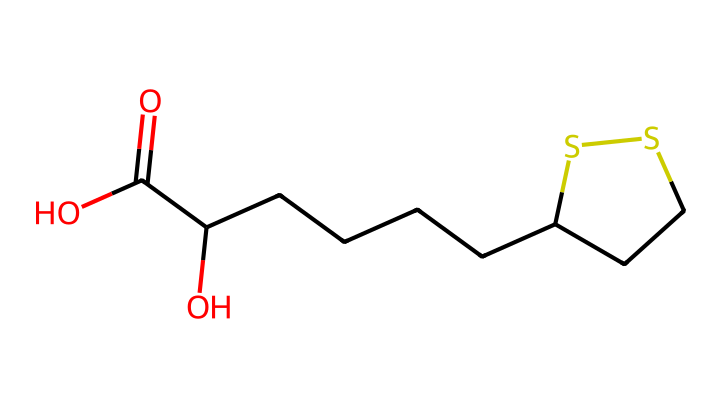What is the molecular formula of alpha-lipoic acid? By analyzing the SMILES representation, we can identify the components which typically include carbon (C), hydrogen (H), oxygen (O), and sulfur (S). Counting the atoms, we find there are 8 carbon atoms, 14 hydrogen atoms, 2 oxygen atoms, and 2 sulfur atoms. This leads us to the molecular formula, which combines these counts.
Answer: C8H14O2S2 How many sulfur atoms are in alpha-lipoic acid? In the SMILES notation, the "S" represents sulfur atoms. By counting the occurrences of "S," we find there are 2 sulfur atoms in the compound.
Answer: 2 What type of functional groups are present in alpha-lipoic acid? Observing the SMILES structure, we notice a hydroxyl group (-OH) and a carboxylic acid group (-COOH) based on the presence of "O" atoms bonded to hydrogen and the carbonyl (C=O) structure. This indicates functional groups typical for acids and alcohols.
Answer: hydroxyl and carboxylic acid How many carbon chains are evident in the structure of alpha-lipoic acid? The SMILES string reveals a long chain of carbon atoms connected in a linear and branched manner. The presence of "CC" indicates carbon chains while following the structure shows that there is a main chain of 8 carbon atoms, some of which are branched, specifically considering cyclic structures too.
Answer: 1 main chain What is the role of alpha-lipoic acid as an antioxidant? Alpha-lipoic acid functions as an antioxidant by neutralizing free radicals due to the presence of sulfur atoms that can donate electrons. The molecular structure supports this function by being able to participate in redox reactions, effectively scavenging reactive oxygen species and reducing oxidative stress.
Answer: antioxidant What are the implications of the two sulfur atoms in alpha-lipoic acid's functionality? The sulfur atoms contribute to the antioxidant properties by forming disulfide bridges and participating in redox reactions, which enhance the compound's ability to scavenge free radicals and regenerate other antioxidants in the body. This two-sulfur structure is significant for its biochemical activities.
Answer: antioxidant activity 